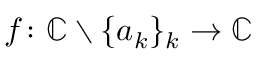<formula> <loc_0><loc_0><loc_500><loc_500>f \colon \mathbb { C } \ \{ a _ { k } \} _ { k } \rightarrow \mathbb { C }</formula> 